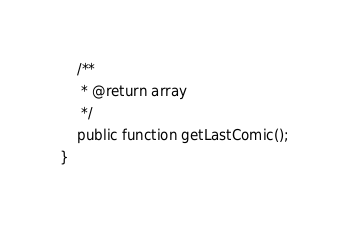<code> <loc_0><loc_0><loc_500><loc_500><_PHP_>
    /**
     * @return array
     */
    public function getLastComic();
}
</code> 